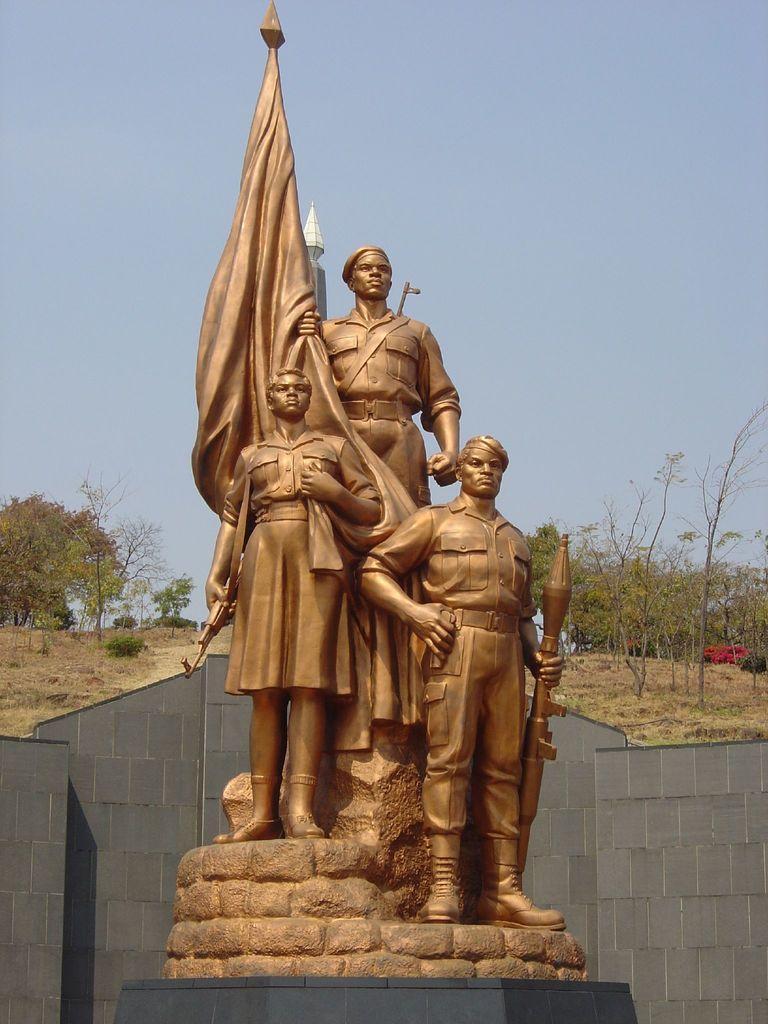Please provide a concise description of this image. In the middle of the image we can see some statues. Behind the statues there is wall. Behind the wall there are some trees. At the top of the image there is sky. 